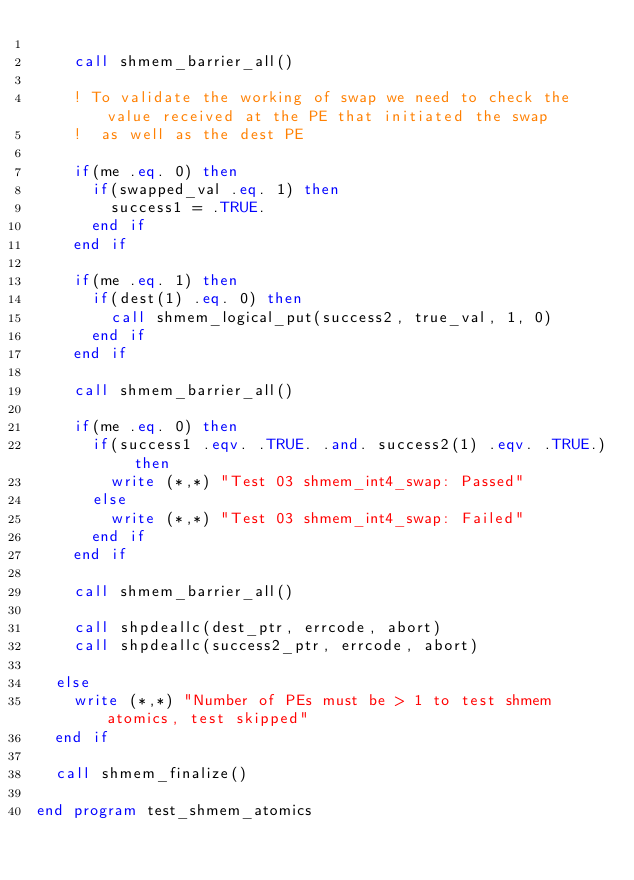<code> <loc_0><loc_0><loc_500><loc_500><_FORTRAN_>
    call shmem_barrier_all()

    ! To validate the working of swap we need to check the value received at the PE that initiated the swap
    !  as well as the dest PE

    if(me .eq. 0) then
      if(swapped_val .eq. 1) then
        success1 = .TRUE.
      end if
    end if

    if(me .eq. 1) then
      if(dest(1) .eq. 0) then
        call shmem_logical_put(success2, true_val, 1, 0)
      end if
    end if

    call shmem_barrier_all()

    if(me .eq. 0) then
      if(success1 .eqv. .TRUE. .and. success2(1) .eqv. .TRUE.) then
        write (*,*) "Test 03 shmem_int4_swap: Passed"
      else
        write (*,*) "Test 03 shmem_int4_swap: Failed"
      end if
    end if

    call shmem_barrier_all()

    call shpdeallc(dest_ptr, errcode, abort)
    call shpdeallc(success2_ptr, errcode, abort)

  else
    write (*,*) "Number of PEs must be > 1 to test shmem atomics, test skipped"
  end if

  call shmem_finalize()

end program test_shmem_atomics
</code> 